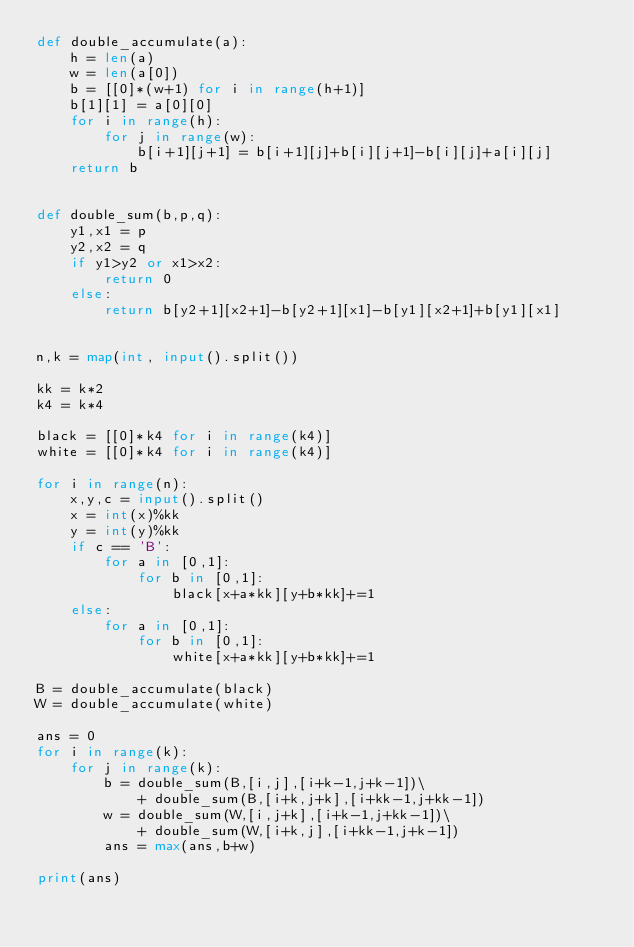<code> <loc_0><loc_0><loc_500><loc_500><_Python_>def double_accumulate(a):
    h = len(a)
    w = len(a[0])
    b = [[0]*(w+1) for i in range(h+1)]
    b[1][1] = a[0][0]
    for i in range(h):
        for j in range(w):
            b[i+1][j+1] = b[i+1][j]+b[i][j+1]-b[i][j]+a[i][j]
    return b


def double_sum(b,p,q):
    y1,x1 = p
    y2,x2 = q
    if y1>y2 or x1>x2:
        return 0
    else:
        return b[y2+1][x2+1]-b[y2+1][x1]-b[y1][x2+1]+b[y1][x1]


n,k = map(int, input().split())

kk = k*2
k4 = k*4

black = [[0]*k4 for i in range(k4)]
white = [[0]*k4 for i in range(k4)]

for i in range(n):
    x,y,c = input().split()
    x = int(x)%kk
    y = int(y)%kk
    if c == 'B':
        for a in [0,1]:
            for b in [0,1]:
                black[x+a*kk][y+b*kk]+=1
    else:
        for a in [0,1]:
            for b in [0,1]:
                white[x+a*kk][y+b*kk]+=1

B = double_accumulate(black)
W = double_accumulate(white)

ans = 0
for i in range(k):
    for j in range(k):
        b = double_sum(B,[i,j],[i+k-1,j+k-1])\
            + double_sum(B,[i+k,j+k],[i+kk-1,j+kk-1])
        w = double_sum(W,[i,j+k],[i+k-1,j+kk-1])\
            + double_sum(W,[i+k,j],[i+kk-1,j+k-1])
        ans = max(ans,b+w)

print(ans)
</code> 